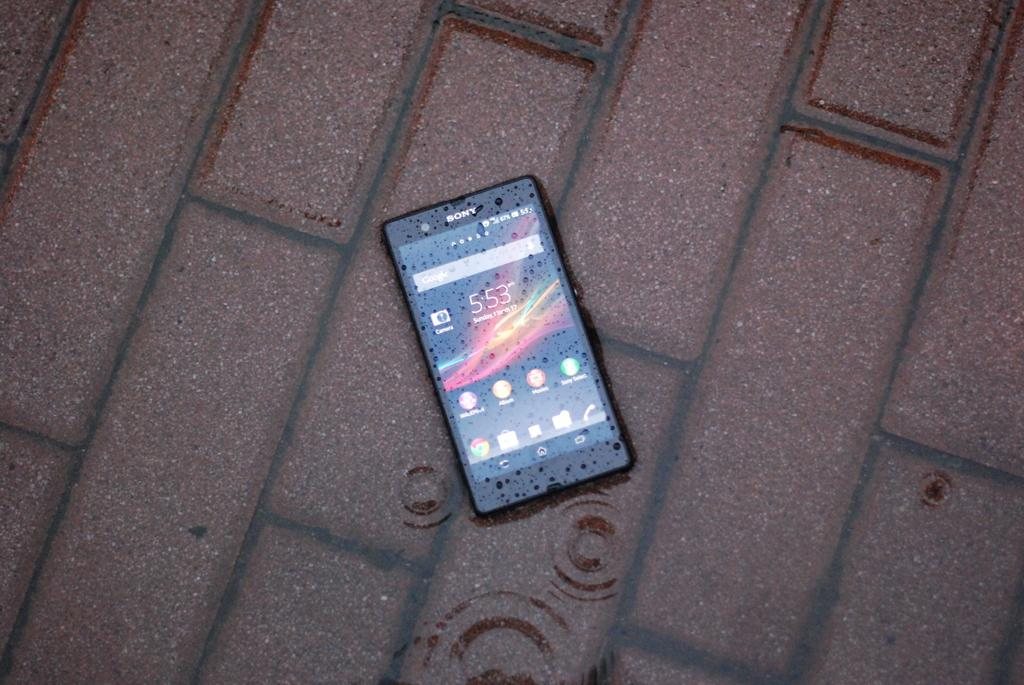Provide a one-sentence caption for the provided image. The Sony cell phone is displaying time 5:53. 